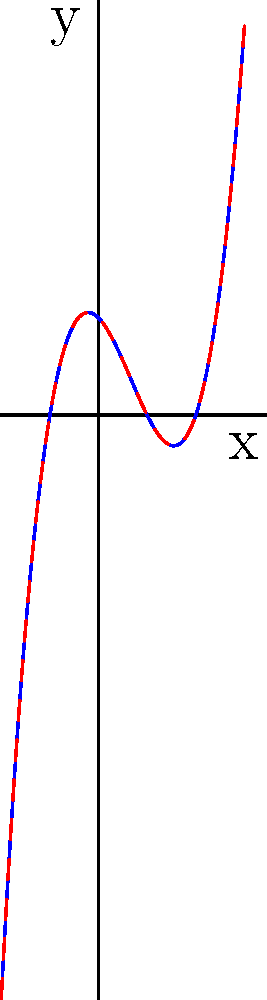Consider the polynomial function $f(x) = x^3 - 2x^2 - x + 2$. After factoring, it becomes $g(x) = (x-2)(x+1)(x-1)$. Analyze the graph and explain how the factored form reveals the x-intercepts of the function. How does this relate to the roots of the polynomial equation $f(x) = 0$? 1. The blue curve represents $f(x) = x^3 - 2x^2 - x + 2$ before factoring.
2. The red dashed curve represents $g(x) = (x-2)(x+1)(x-1)$ after factoring.
3. Both curves are identical because they represent the same function.
4. The factored form $g(x) = (x-2)(x+1)(x-1)$ reveals three linear factors:
   a. $(x-2)$ implies a root at $x=2$
   b. $(x+1)$ implies a root at $x=-1$
   c. $(x-1)$ implies a root at $x=1$
5. These roots correspond to the x-intercepts of the graph, where $y=0$.
6. The x-intercepts occur at $x=-1$, $x=1$, and $x=2$, as seen on the graph.
7. The roots of the polynomial equation $f(x) = 0$ are the same as the x-intercepts.
8. Factoring helps identify these roots without solving the cubic equation algebraically.
9. The graph visually confirms the algebraic factorization, showing how polynomial structure relates to graph features.
Answer: Factoring reveals x-intercepts at $x=-1$, $1$, and $2$, which are the roots of $f(x)=0$. 